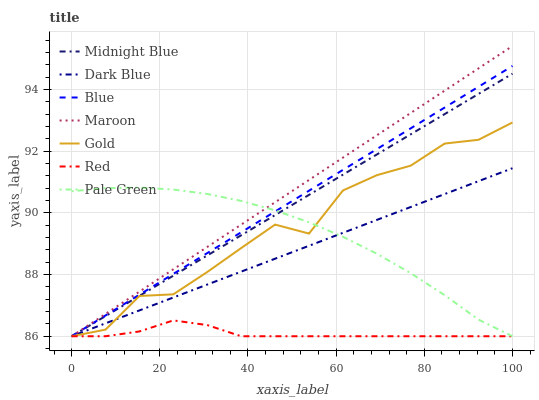Does Midnight Blue have the minimum area under the curve?
Answer yes or no. No. Does Midnight Blue have the maximum area under the curve?
Answer yes or no. No. Is Midnight Blue the smoothest?
Answer yes or no. No. Is Midnight Blue the roughest?
Answer yes or no. No. Does Midnight Blue have the highest value?
Answer yes or no. No. 